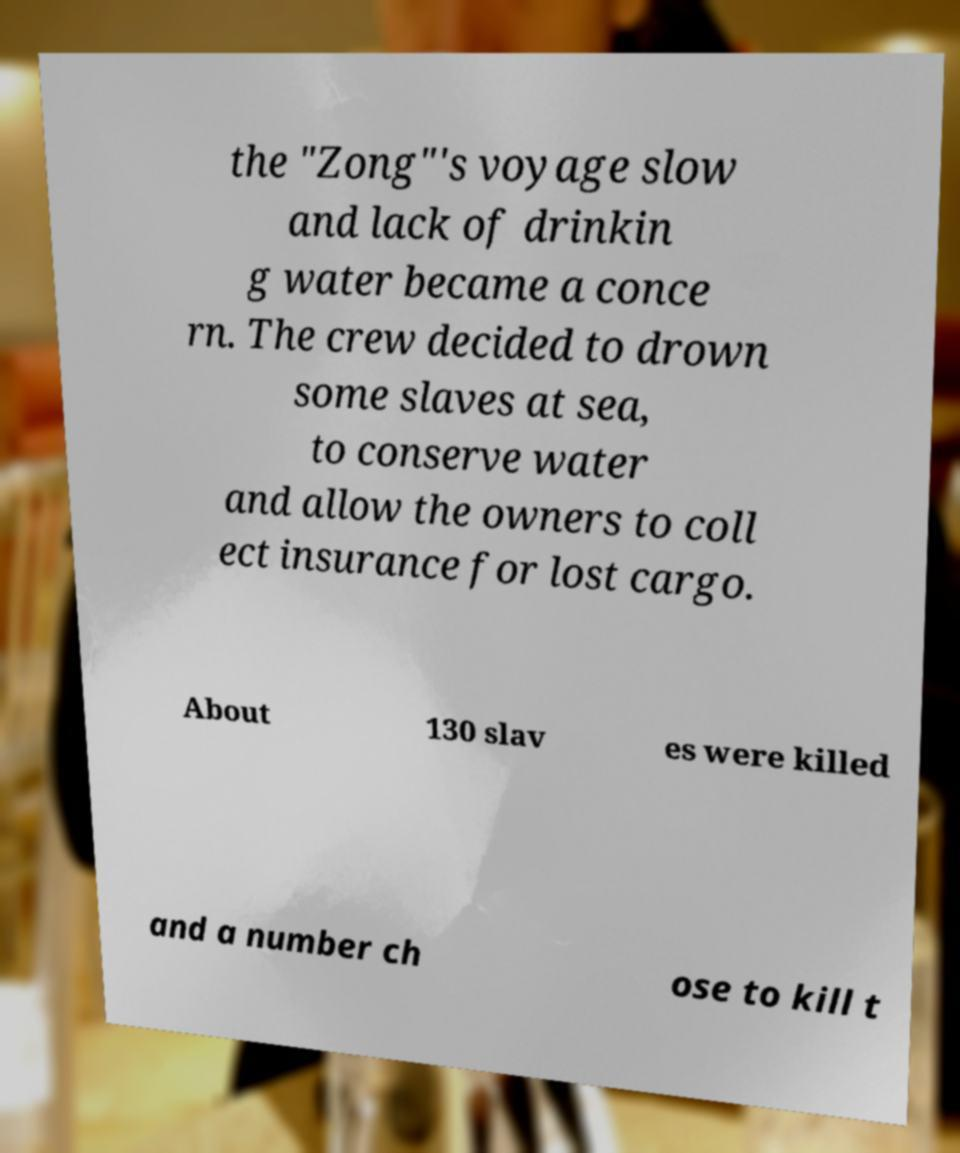Can you read and provide the text displayed in the image?This photo seems to have some interesting text. Can you extract and type it out for me? the "Zong"'s voyage slow and lack of drinkin g water became a conce rn. The crew decided to drown some slaves at sea, to conserve water and allow the owners to coll ect insurance for lost cargo. About 130 slav es were killed and a number ch ose to kill t 